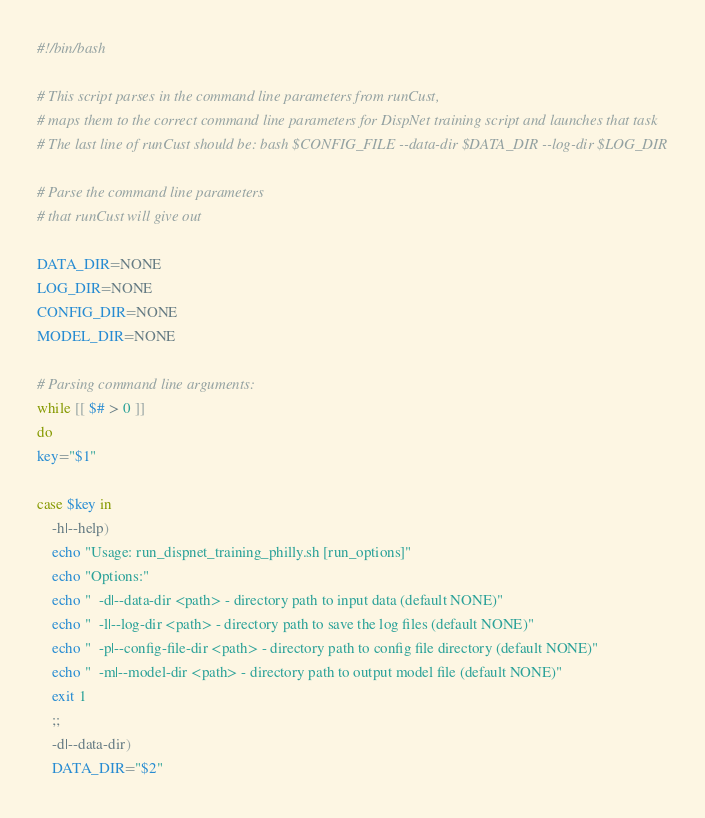Convert code to text. <code><loc_0><loc_0><loc_500><loc_500><_Bash_>#!/bin/bash

# This script parses in the command line parameters from runCust, 
# maps them to the correct command line parameters for DispNet training script and launches that task
# The last line of runCust should be: bash $CONFIG_FILE --data-dir $DATA_DIR --log-dir $LOG_DIR

# Parse the command line parameters
# that runCust will give out

DATA_DIR=NONE
LOG_DIR=NONE
CONFIG_DIR=NONE
MODEL_DIR=NONE

# Parsing command line arguments:
while [[ $# > 0 ]]
do
key="$1"

case $key in
    -h|--help)
    echo "Usage: run_dispnet_training_philly.sh [run_options]"
    echo "Options:"
    echo "  -d|--data-dir <path> - directory path to input data (default NONE)"
    echo "  -l|--log-dir <path> - directory path to save the log files (default NONE)"
    echo "  -p|--config-file-dir <path> - directory path to config file directory (default NONE)"
    echo "  -m|--model-dir <path> - directory path to output model file (default NONE)"
    exit 1
    ;;
    -d|--data-dir)
    DATA_DIR="$2"</code> 